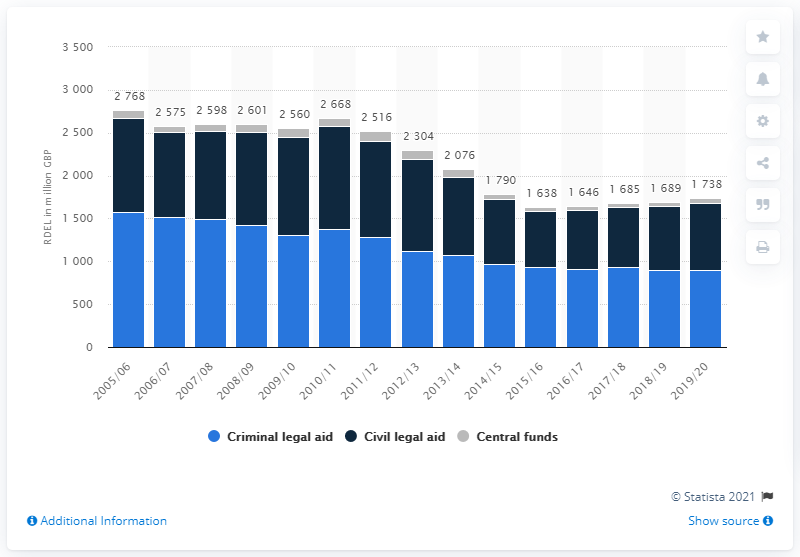Draw attention to some important aspects in this diagram. In the year 2019/20, the budget for criminal legal aid in England and Wales was 897 million pounds. In the 2015/2016 fiscal year, the civil legal aid budget was approximately 651. Criminal legal aid reached its peak in the 2005/2006 fiscal year with a total of 1,573. 